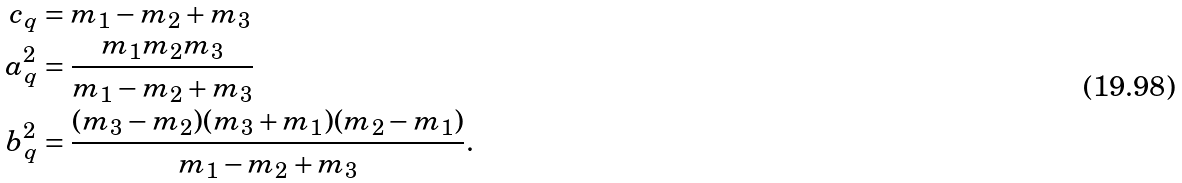<formula> <loc_0><loc_0><loc_500><loc_500>c _ { q } & = m _ { 1 } - m _ { 2 } + m _ { 3 } \\ a _ { q } ^ { 2 } & = \frac { m _ { 1 } m _ { 2 } m _ { 3 } } { m _ { 1 } - m _ { 2 } + m _ { 3 } } \\ b _ { q } ^ { 2 } & = \frac { ( m _ { 3 } - m _ { 2 } ) ( m _ { 3 } + m _ { 1 } ) ( m _ { 2 } - m _ { 1 } ) } { m _ { 1 } - m _ { 2 } + m _ { 3 } } .</formula> 